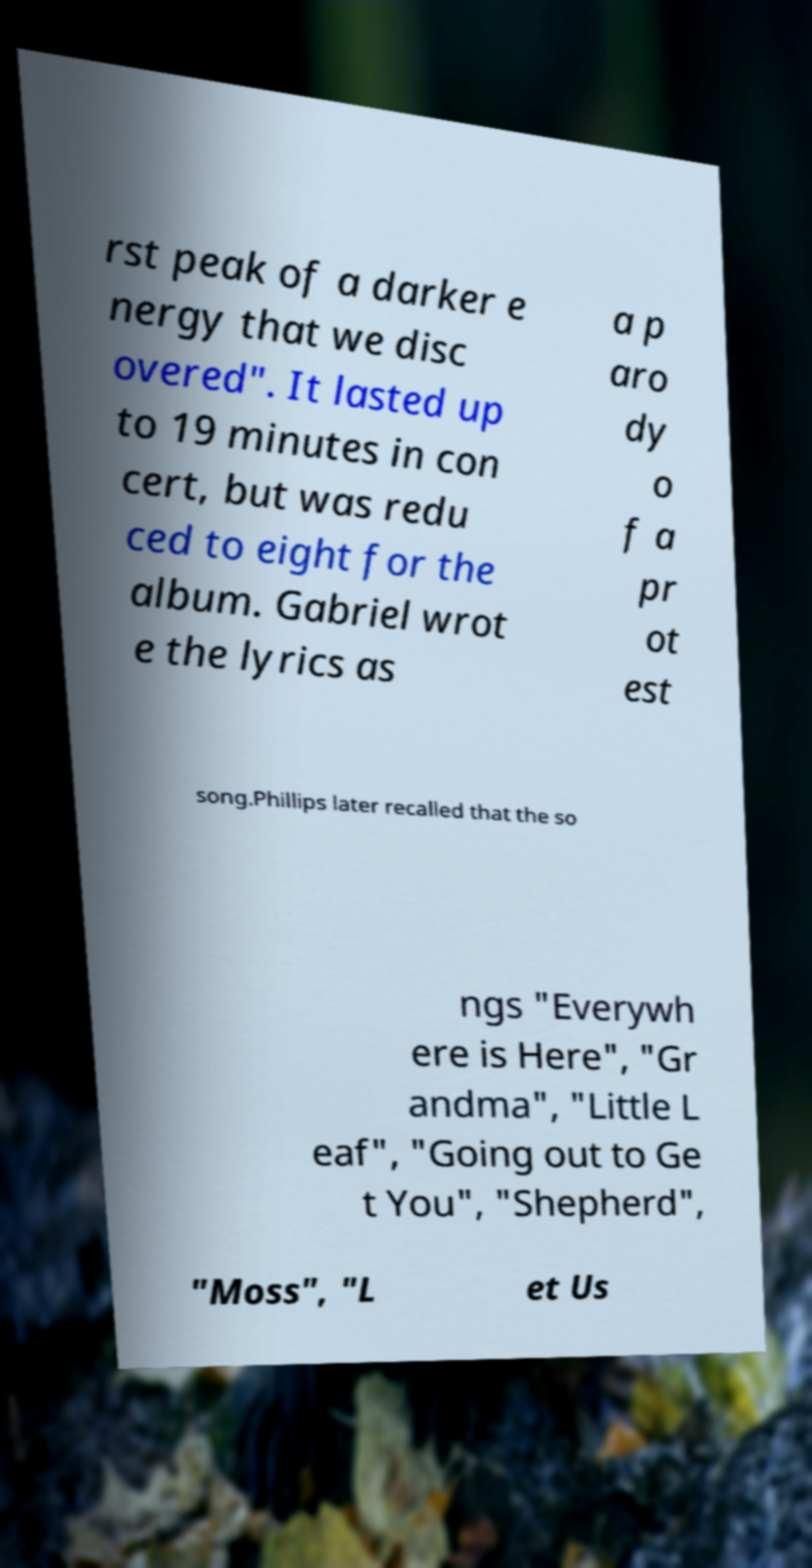Please identify and transcribe the text found in this image. rst peak of a darker e nergy that we disc overed". It lasted up to 19 minutes in con cert, but was redu ced to eight for the album. Gabriel wrot e the lyrics as a p aro dy o f a pr ot est song.Phillips later recalled that the so ngs "Everywh ere is Here", "Gr andma", "Little L eaf", "Going out to Ge t You", "Shepherd", "Moss", "L et Us 